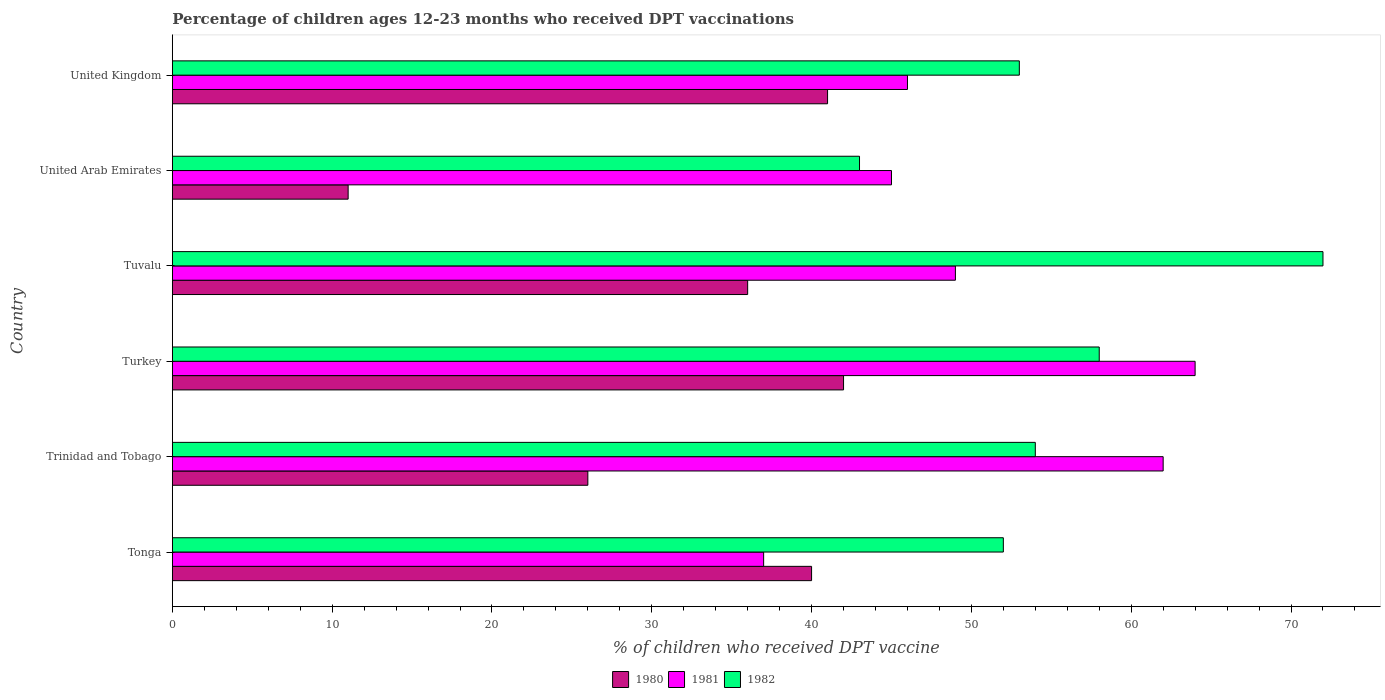How many bars are there on the 5th tick from the bottom?
Keep it short and to the point. 3. What is the percentage of children who received DPT vaccination in 1981 in Tonga?
Your answer should be very brief. 37. In which country was the percentage of children who received DPT vaccination in 1981 maximum?
Provide a succinct answer. Turkey. In which country was the percentage of children who received DPT vaccination in 1980 minimum?
Give a very brief answer. United Arab Emirates. What is the total percentage of children who received DPT vaccination in 1980 in the graph?
Ensure brevity in your answer.  196. What is the difference between the percentage of children who received DPT vaccination in 1981 in Turkey and that in United Arab Emirates?
Provide a succinct answer. 19. What is the average percentage of children who received DPT vaccination in 1982 per country?
Give a very brief answer. 55.33. What is the difference between the percentage of children who received DPT vaccination in 1981 and percentage of children who received DPT vaccination in 1982 in United Kingdom?
Give a very brief answer. -7. What is the ratio of the percentage of children who received DPT vaccination in 1981 in Tuvalu to that in United Kingdom?
Provide a succinct answer. 1.07. Is the percentage of children who received DPT vaccination in 1982 in Turkey less than that in Tuvalu?
Offer a terse response. Yes. Is the difference between the percentage of children who received DPT vaccination in 1981 in Tonga and United Arab Emirates greater than the difference between the percentage of children who received DPT vaccination in 1982 in Tonga and United Arab Emirates?
Your response must be concise. No. Is the sum of the percentage of children who received DPT vaccination in 1981 in Tonga and Tuvalu greater than the maximum percentage of children who received DPT vaccination in 1980 across all countries?
Provide a short and direct response. Yes. What does the 1st bar from the bottom in Trinidad and Tobago represents?
Offer a terse response. 1980. How many bars are there?
Offer a terse response. 18. Are the values on the major ticks of X-axis written in scientific E-notation?
Your answer should be compact. No. Does the graph contain any zero values?
Your response must be concise. No. Does the graph contain grids?
Offer a terse response. No. What is the title of the graph?
Make the answer very short. Percentage of children ages 12-23 months who received DPT vaccinations. Does "1976" appear as one of the legend labels in the graph?
Ensure brevity in your answer.  No. What is the label or title of the X-axis?
Your answer should be compact. % of children who received DPT vaccine. What is the % of children who received DPT vaccine in 1981 in Trinidad and Tobago?
Give a very brief answer. 62. What is the % of children who received DPT vaccine in 1980 in Turkey?
Your answer should be very brief. 42. What is the % of children who received DPT vaccine in 1982 in Turkey?
Offer a terse response. 58. What is the % of children who received DPT vaccine of 1980 in Tuvalu?
Provide a short and direct response. 36. What is the % of children who received DPT vaccine of 1980 in United Arab Emirates?
Ensure brevity in your answer.  11. What is the % of children who received DPT vaccine in 1982 in United Arab Emirates?
Offer a very short reply. 43. What is the % of children who received DPT vaccine in 1981 in United Kingdom?
Your answer should be very brief. 46. What is the % of children who received DPT vaccine in 1982 in United Kingdom?
Offer a very short reply. 53. Across all countries, what is the maximum % of children who received DPT vaccine of 1981?
Provide a succinct answer. 64. Across all countries, what is the minimum % of children who received DPT vaccine in 1980?
Provide a short and direct response. 11. What is the total % of children who received DPT vaccine in 1980 in the graph?
Keep it short and to the point. 196. What is the total % of children who received DPT vaccine in 1981 in the graph?
Offer a very short reply. 303. What is the total % of children who received DPT vaccine of 1982 in the graph?
Give a very brief answer. 332. What is the difference between the % of children who received DPT vaccine in 1981 in Tonga and that in Trinidad and Tobago?
Provide a short and direct response. -25. What is the difference between the % of children who received DPT vaccine of 1982 in Tonga and that in Trinidad and Tobago?
Offer a terse response. -2. What is the difference between the % of children who received DPT vaccine of 1980 in Tonga and that in Turkey?
Offer a terse response. -2. What is the difference between the % of children who received DPT vaccine of 1980 in Tonga and that in Tuvalu?
Ensure brevity in your answer.  4. What is the difference between the % of children who received DPT vaccine in 1981 in Tonga and that in Tuvalu?
Keep it short and to the point. -12. What is the difference between the % of children who received DPT vaccine of 1982 in Tonga and that in Tuvalu?
Your answer should be compact. -20. What is the difference between the % of children who received DPT vaccine of 1981 in Tonga and that in United Arab Emirates?
Give a very brief answer. -8. What is the difference between the % of children who received DPT vaccine of 1982 in Tonga and that in United Arab Emirates?
Provide a short and direct response. 9. What is the difference between the % of children who received DPT vaccine in 1980 in Tonga and that in United Kingdom?
Give a very brief answer. -1. What is the difference between the % of children who received DPT vaccine of 1981 in Tonga and that in United Kingdom?
Offer a very short reply. -9. What is the difference between the % of children who received DPT vaccine in 1981 in Trinidad and Tobago and that in Turkey?
Ensure brevity in your answer.  -2. What is the difference between the % of children who received DPT vaccine in 1982 in Trinidad and Tobago and that in Tuvalu?
Make the answer very short. -18. What is the difference between the % of children who received DPT vaccine of 1981 in Trinidad and Tobago and that in United Arab Emirates?
Ensure brevity in your answer.  17. What is the difference between the % of children who received DPT vaccine of 1980 in Trinidad and Tobago and that in United Kingdom?
Keep it short and to the point. -15. What is the difference between the % of children who received DPT vaccine in 1981 in Trinidad and Tobago and that in United Kingdom?
Keep it short and to the point. 16. What is the difference between the % of children who received DPT vaccine of 1982 in Trinidad and Tobago and that in United Kingdom?
Give a very brief answer. 1. What is the difference between the % of children who received DPT vaccine in 1980 in Turkey and that in Tuvalu?
Give a very brief answer. 6. What is the difference between the % of children who received DPT vaccine of 1981 in Turkey and that in Tuvalu?
Your answer should be compact. 15. What is the difference between the % of children who received DPT vaccine in 1982 in Turkey and that in Tuvalu?
Give a very brief answer. -14. What is the difference between the % of children who received DPT vaccine in 1982 in Turkey and that in United Arab Emirates?
Make the answer very short. 15. What is the difference between the % of children who received DPT vaccine of 1981 in Turkey and that in United Kingdom?
Make the answer very short. 18. What is the difference between the % of children who received DPT vaccine in 1982 in Turkey and that in United Kingdom?
Your response must be concise. 5. What is the difference between the % of children who received DPT vaccine in 1980 in Tuvalu and that in United Arab Emirates?
Keep it short and to the point. 25. What is the difference between the % of children who received DPT vaccine of 1980 in Tuvalu and that in United Kingdom?
Make the answer very short. -5. What is the difference between the % of children who received DPT vaccine of 1982 in Tuvalu and that in United Kingdom?
Offer a terse response. 19. What is the difference between the % of children who received DPT vaccine of 1980 in Tonga and the % of children who received DPT vaccine of 1982 in Trinidad and Tobago?
Your response must be concise. -14. What is the difference between the % of children who received DPT vaccine in 1980 in Tonga and the % of children who received DPT vaccine in 1982 in Turkey?
Offer a very short reply. -18. What is the difference between the % of children who received DPT vaccine of 1980 in Tonga and the % of children who received DPT vaccine of 1982 in Tuvalu?
Keep it short and to the point. -32. What is the difference between the % of children who received DPT vaccine of 1981 in Tonga and the % of children who received DPT vaccine of 1982 in Tuvalu?
Your answer should be very brief. -35. What is the difference between the % of children who received DPT vaccine of 1980 in Tonga and the % of children who received DPT vaccine of 1981 in United Kingdom?
Provide a succinct answer. -6. What is the difference between the % of children who received DPT vaccine in 1980 in Tonga and the % of children who received DPT vaccine in 1982 in United Kingdom?
Your answer should be compact. -13. What is the difference between the % of children who received DPT vaccine in 1980 in Trinidad and Tobago and the % of children who received DPT vaccine in 1981 in Turkey?
Give a very brief answer. -38. What is the difference between the % of children who received DPT vaccine in 1980 in Trinidad and Tobago and the % of children who received DPT vaccine in 1982 in Turkey?
Your answer should be compact. -32. What is the difference between the % of children who received DPT vaccine of 1980 in Trinidad and Tobago and the % of children who received DPT vaccine of 1981 in Tuvalu?
Offer a terse response. -23. What is the difference between the % of children who received DPT vaccine in 1980 in Trinidad and Tobago and the % of children who received DPT vaccine in 1982 in Tuvalu?
Offer a terse response. -46. What is the difference between the % of children who received DPT vaccine of 1980 in Trinidad and Tobago and the % of children who received DPT vaccine of 1981 in United Arab Emirates?
Provide a short and direct response. -19. What is the difference between the % of children who received DPT vaccine in 1980 in Trinidad and Tobago and the % of children who received DPT vaccine in 1982 in United Arab Emirates?
Offer a very short reply. -17. What is the difference between the % of children who received DPT vaccine of 1981 in Trinidad and Tobago and the % of children who received DPT vaccine of 1982 in United Arab Emirates?
Make the answer very short. 19. What is the difference between the % of children who received DPT vaccine in 1981 in Trinidad and Tobago and the % of children who received DPT vaccine in 1982 in United Kingdom?
Offer a terse response. 9. What is the difference between the % of children who received DPT vaccine in 1980 in Turkey and the % of children who received DPT vaccine in 1982 in Tuvalu?
Provide a short and direct response. -30. What is the difference between the % of children who received DPT vaccine of 1980 in Turkey and the % of children who received DPT vaccine of 1982 in United Arab Emirates?
Provide a succinct answer. -1. What is the difference between the % of children who received DPT vaccine of 1980 in Tuvalu and the % of children who received DPT vaccine of 1981 in United Arab Emirates?
Keep it short and to the point. -9. What is the difference between the % of children who received DPT vaccine in 1981 in Tuvalu and the % of children who received DPT vaccine in 1982 in United Arab Emirates?
Your answer should be compact. 6. What is the difference between the % of children who received DPT vaccine of 1981 in Tuvalu and the % of children who received DPT vaccine of 1982 in United Kingdom?
Make the answer very short. -4. What is the difference between the % of children who received DPT vaccine in 1980 in United Arab Emirates and the % of children who received DPT vaccine in 1981 in United Kingdom?
Offer a terse response. -35. What is the difference between the % of children who received DPT vaccine in 1980 in United Arab Emirates and the % of children who received DPT vaccine in 1982 in United Kingdom?
Offer a terse response. -42. What is the difference between the % of children who received DPT vaccine of 1981 in United Arab Emirates and the % of children who received DPT vaccine of 1982 in United Kingdom?
Offer a very short reply. -8. What is the average % of children who received DPT vaccine in 1980 per country?
Give a very brief answer. 32.67. What is the average % of children who received DPT vaccine of 1981 per country?
Offer a very short reply. 50.5. What is the average % of children who received DPT vaccine in 1982 per country?
Provide a succinct answer. 55.33. What is the difference between the % of children who received DPT vaccine in 1980 and % of children who received DPT vaccine in 1981 in Tonga?
Offer a terse response. 3. What is the difference between the % of children who received DPT vaccine in 1980 and % of children who received DPT vaccine in 1981 in Trinidad and Tobago?
Offer a terse response. -36. What is the difference between the % of children who received DPT vaccine in 1980 and % of children who received DPT vaccine in 1981 in Turkey?
Offer a very short reply. -22. What is the difference between the % of children who received DPT vaccine of 1980 and % of children who received DPT vaccine of 1981 in Tuvalu?
Offer a terse response. -13. What is the difference between the % of children who received DPT vaccine of 1980 and % of children who received DPT vaccine of 1982 in Tuvalu?
Your answer should be compact. -36. What is the difference between the % of children who received DPT vaccine of 1980 and % of children who received DPT vaccine of 1981 in United Arab Emirates?
Offer a very short reply. -34. What is the difference between the % of children who received DPT vaccine in 1980 and % of children who received DPT vaccine in 1982 in United Arab Emirates?
Make the answer very short. -32. What is the difference between the % of children who received DPT vaccine of 1980 and % of children who received DPT vaccine of 1981 in United Kingdom?
Make the answer very short. -5. What is the difference between the % of children who received DPT vaccine in 1980 and % of children who received DPT vaccine in 1982 in United Kingdom?
Ensure brevity in your answer.  -12. What is the difference between the % of children who received DPT vaccine of 1981 and % of children who received DPT vaccine of 1982 in United Kingdom?
Provide a succinct answer. -7. What is the ratio of the % of children who received DPT vaccine in 1980 in Tonga to that in Trinidad and Tobago?
Provide a short and direct response. 1.54. What is the ratio of the % of children who received DPT vaccine in 1981 in Tonga to that in Trinidad and Tobago?
Provide a succinct answer. 0.6. What is the ratio of the % of children who received DPT vaccine in 1981 in Tonga to that in Turkey?
Keep it short and to the point. 0.58. What is the ratio of the % of children who received DPT vaccine of 1982 in Tonga to that in Turkey?
Make the answer very short. 0.9. What is the ratio of the % of children who received DPT vaccine of 1980 in Tonga to that in Tuvalu?
Give a very brief answer. 1.11. What is the ratio of the % of children who received DPT vaccine in 1981 in Tonga to that in Tuvalu?
Ensure brevity in your answer.  0.76. What is the ratio of the % of children who received DPT vaccine in 1982 in Tonga to that in Tuvalu?
Make the answer very short. 0.72. What is the ratio of the % of children who received DPT vaccine of 1980 in Tonga to that in United Arab Emirates?
Your answer should be very brief. 3.64. What is the ratio of the % of children who received DPT vaccine in 1981 in Tonga to that in United Arab Emirates?
Ensure brevity in your answer.  0.82. What is the ratio of the % of children who received DPT vaccine in 1982 in Tonga to that in United Arab Emirates?
Keep it short and to the point. 1.21. What is the ratio of the % of children who received DPT vaccine of 1980 in Tonga to that in United Kingdom?
Provide a succinct answer. 0.98. What is the ratio of the % of children who received DPT vaccine of 1981 in Tonga to that in United Kingdom?
Your answer should be compact. 0.8. What is the ratio of the % of children who received DPT vaccine in 1982 in Tonga to that in United Kingdom?
Offer a very short reply. 0.98. What is the ratio of the % of children who received DPT vaccine of 1980 in Trinidad and Tobago to that in Turkey?
Make the answer very short. 0.62. What is the ratio of the % of children who received DPT vaccine of 1981 in Trinidad and Tobago to that in Turkey?
Make the answer very short. 0.97. What is the ratio of the % of children who received DPT vaccine of 1980 in Trinidad and Tobago to that in Tuvalu?
Your answer should be very brief. 0.72. What is the ratio of the % of children who received DPT vaccine in 1981 in Trinidad and Tobago to that in Tuvalu?
Make the answer very short. 1.27. What is the ratio of the % of children who received DPT vaccine in 1980 in Trinidad and Tobago to that in United Arab Emirates?
Keep it short and to the point. 2.36. What is the ratio of the % of children who received DPT vaccine in 1981 in Trinidad and Tobago to that in United Arab Emirates?
Give a very brief answer. 1.38. What is the ratio of the % of children who received DPT vaccine in 1982 in Trinidad and Tobago to that in United Arab Emirates?
Offer a terse response. 1.26. What is the ratio of the % of children who received DPT vaccine in 1980 in Trinidad and Tobago to that in United Kingdom?
Your response must be concise. 0.63. What is the ratio of the % of children who received DPT vaccine of 1981 in Trinidad and Tobago to that in United Kingdom?
Make the answer very short. 1.35. What is the ratio of the % of children who received DPT vaccine in 1982 in Trinidad and Tobago to that in United Kingdom?
Your answer should be compact. 1.02. What is the ratio of the % of children who received DPT vaccine of 1980 in Turkey to that in Tuvalu?
Provide a short and direct response. 1.17. What is the ratio of the % of children who received DPT vaccine in 1981 in Turkey to that in Tuvalu?
Make the answer very short. 1.31. What is the ratio of the % of children who received DPT vaccine of 1982 in Turkey to that in Tuvalu?
Provide a succinct answer. 0.81. What is the ratio of the % of children who received DPT vaccine in 1980 in Turkey to that in United Arab Emirates?
Provide a short and direct response. 3.82. What is the ratio of the % of children who received DPT vaccine of 1981 in Turkey to that in United Arab Emirates?
Make the answer very short. 1.42. What is the ratio of the % of children who received DPT vaccine in 1982 in Turkey to that in United Arab Emirates?
Your response must be concise. 1.35. What is the ratio of the % of children who received DPT vaccine of 1980 in Turkey to that in United Kingdom?
Keep it short and to the point. 1.02. What is the ratio of the % of children who received DPT vaccine in 1981 in Turkey to that in United Kingdom?
Ensure brevity in your answer.  1.39. What is the ratio of the % of children who received DPT vaccine in 1982 in Turkey to that in United Kingdom?
Your response must be concise. 1.09. What is the ratio of the % of children who received DPT vaccine of 1980 in Tuvalu to that in United Arab Emirates?
Offer a terse response. 3.27. What is the ratio of the % of children who received DPT vaccine of 1981 in Tuvalu to that in United Arab Emirates?
Give a very brief answer. 1.09. What is the ratio of the % of children who received DPT vaccine of 1982 in Tuvalu to that in United Arab Emirates?
Provide a short and direct response. 1.67. What is the ratio of the % of children who received DPT vaccine in 1980 in Tuvalu to that in United Kingdom?
Your answer should be very brief. 0.88. What is the ratio of the % of children who received DPT vaccine in 1981 in Tuvalu to that in United Kingdom?
Give a very brief answer. 1.07. What is the ratio of the % of children who received DPT vaccine in 1982 in Tuvalu to that in United Kingdom?
Offer a very short reply. 1.36. What is the ratio of the % of children who received DPT vaccine of 1980 in United Arab Emirates to that in United Kingdom?
Provide a succinct answer. 0.27. What is the ratio of the % of children who received DPT vaccine of 1981 in United Arab Emirates to that in United Kingdom?
Provide a succinct answer. 0.98. What is the ratio of the % of children who received DPT vaccine in 1982 in United Arab Emirates to that in United Kingdom?
Offer a terse response. 0.81. What is the difference between the highest and the second highest % of children who received DPT vaccine of 1982?
Your response must be concise. 14. What is the difference between the highest and the lowest % of children who received DPT vaccine in 1980?
Your answer should be compact. 31. What is the difference between the highest and the lowest % of children who received DPT vaccine of 1981?
Your response must be concise. 27. 